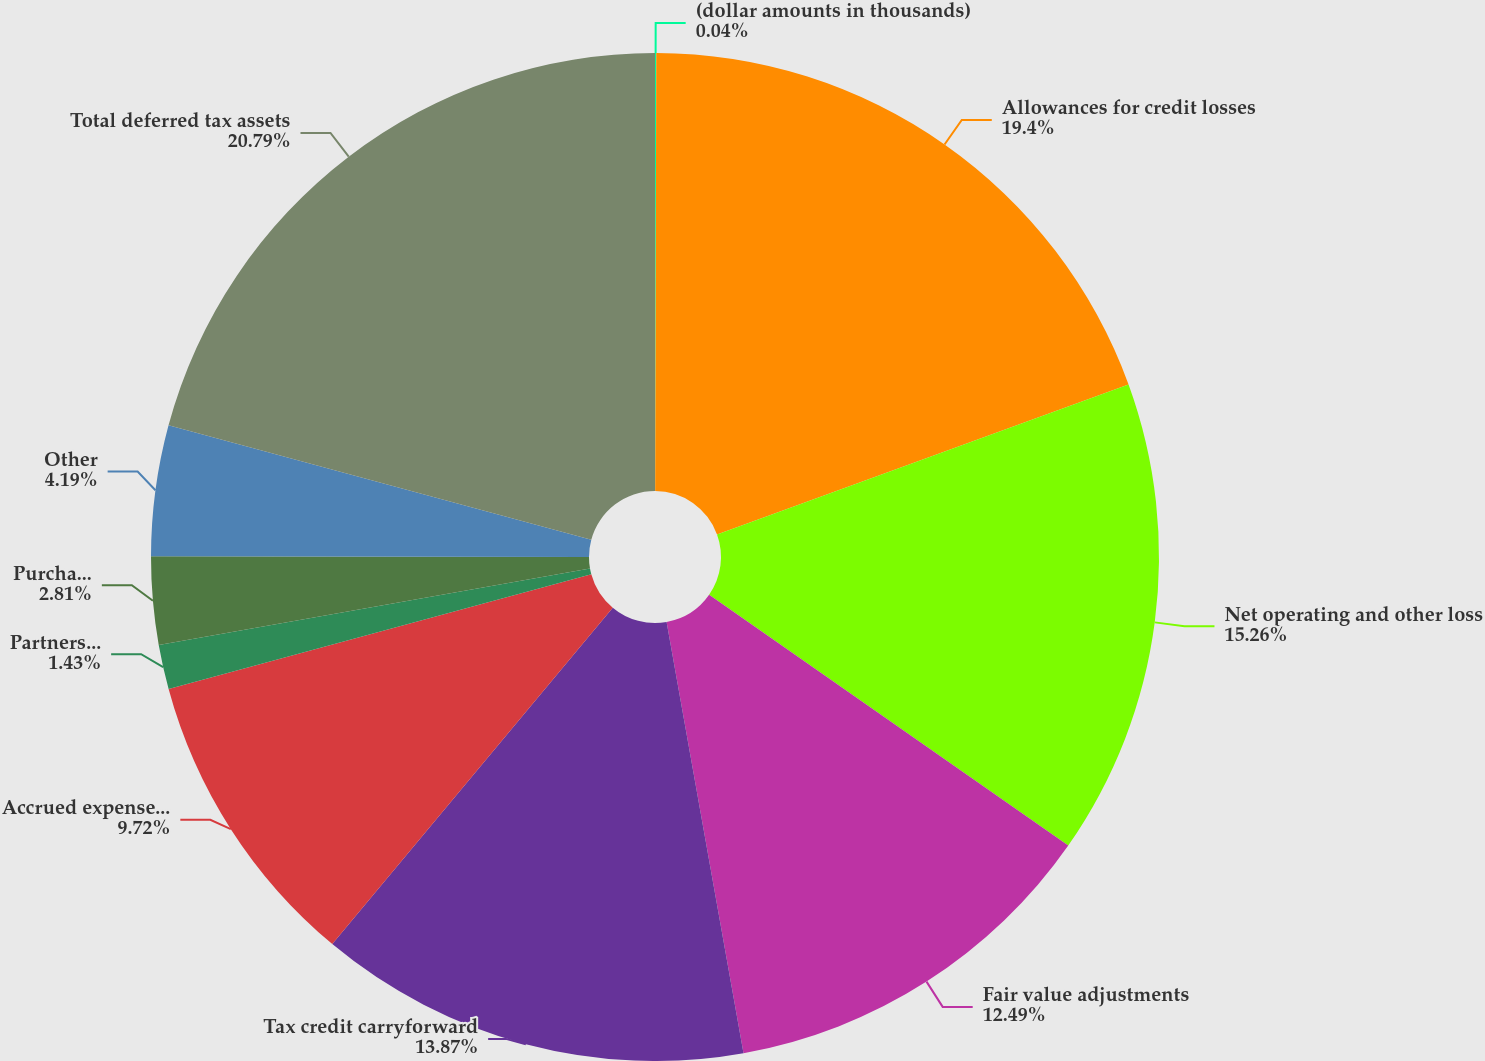Convert chart. <chart><loc_0><loc_0><loc_500><loc_500><pie_chart><fcel>(dollar amounts in thousands)<fcel>Allowances for credit losses<fcel>Net operating and other loss<fcel>Fair value adjustments<fcel>Tax credit carryforward<fcel>Accrued expense/prepaid<fcel>Partnership investments<fcel>Purchase accounting<fcel>Other<fcel>Total deferred tax assets<nl><fcel>0.04%<fcel>19.4%<fcel>15.26%<fcel>12.49%<fcel>13.87%<fcel>9.72%<fcel>1.43%<fcel>2.81%<fcel>4.19%<fcel>20.79%<nl></chart> 